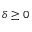Convert formula to latex. <formula><loc_0><loc_0><loc_500><loc_500>\delta \geq 0</formula> 